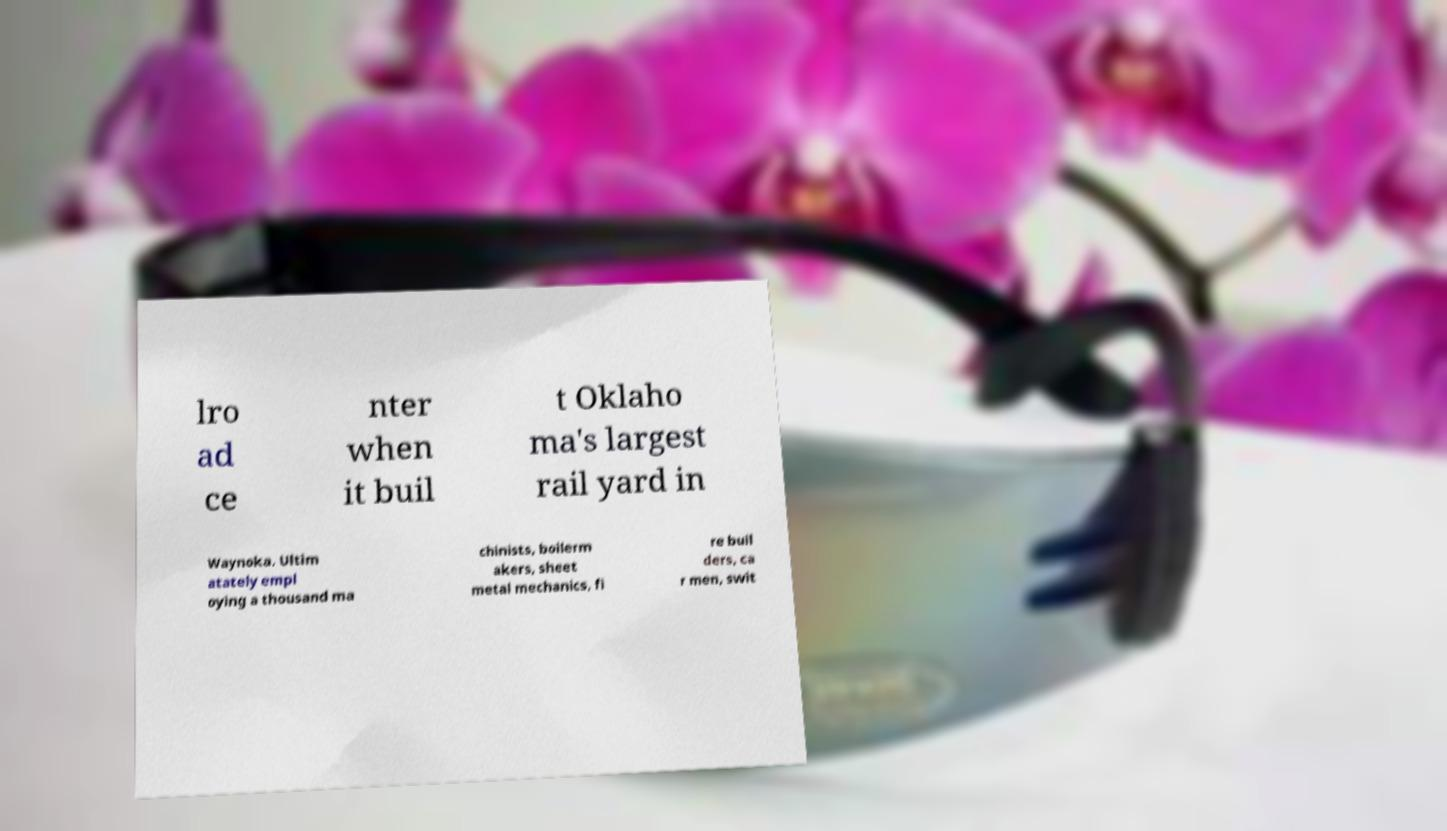Can you accurately transcribe the text from the provided image for me? lro ad ce nter when it buil t Oklaho ma's largest rail yard in Waynoka. Ultim atately empl oying a thousand ma chinists, boilerm akers, sheet metal mechanics, fi re buil ders, ca r men, swit 